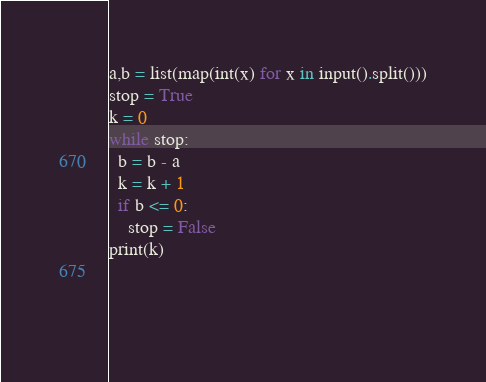<code> <loc_0><loc_0><loc_500><loc_500><_Python_>a,b = list(map(int(x) for x in input().split()))
stop = True
k = 0
while stop:
  b = b - a
  k = k + 1
  if b <= 0:
    stop = False
print(k)
  
  
  </code> 